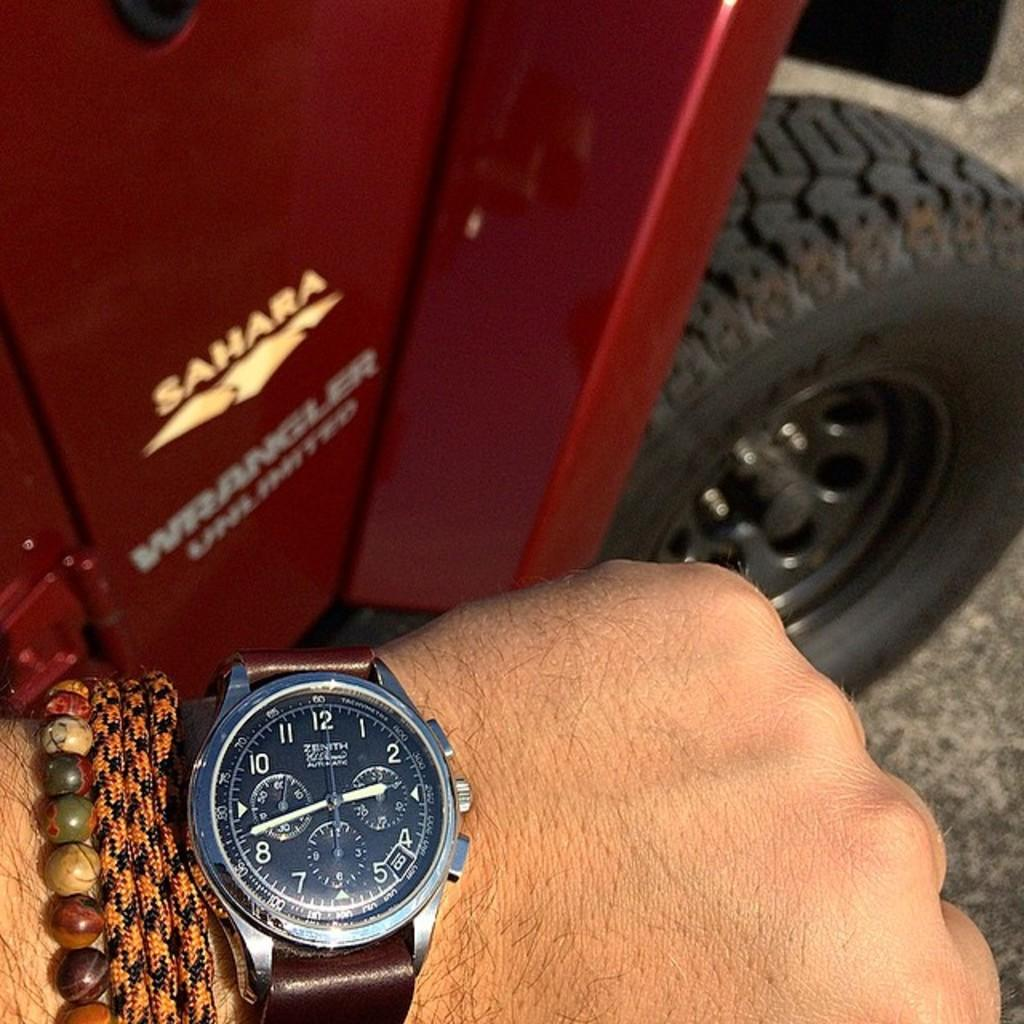<image>
Render a clear and concise summary of the photo. A person holds their Zenith watch out near a sign that says Sahara. 